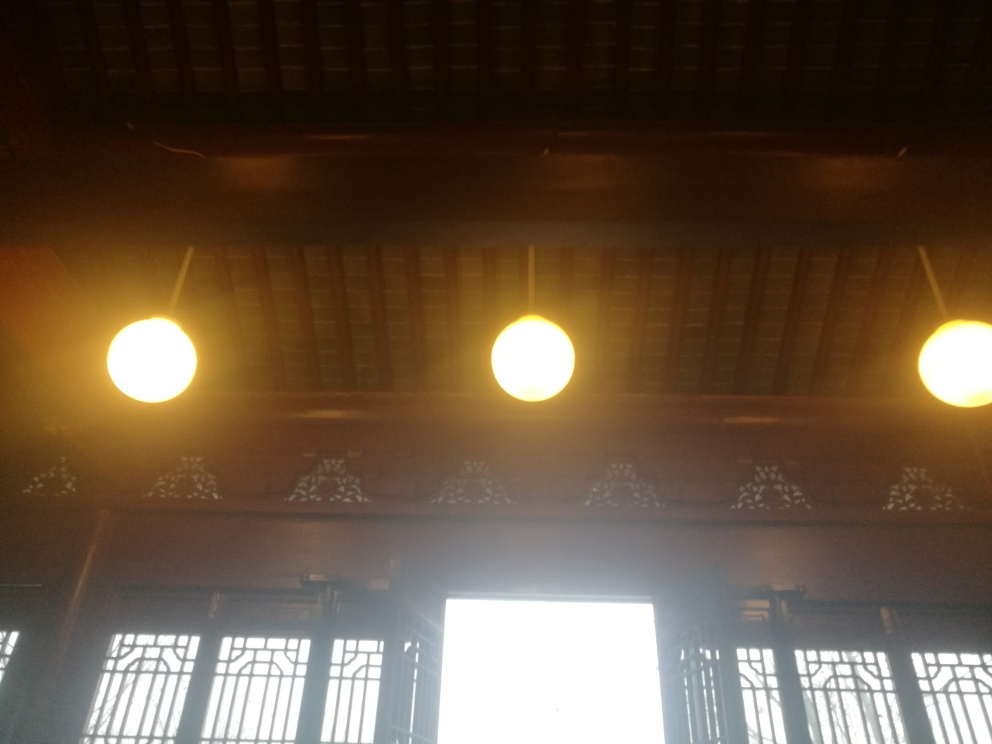What adjustments could be made to better capture the mood of this interior space? To better capture the mood, one could consider lowering the exposure to reduce glare and highlight the warm glow from the hanging lamps. Using a warmer white balance setting could emphasize coziness. If possible, capturing the scene during a different time of day when the light is less intense outside could also help. 